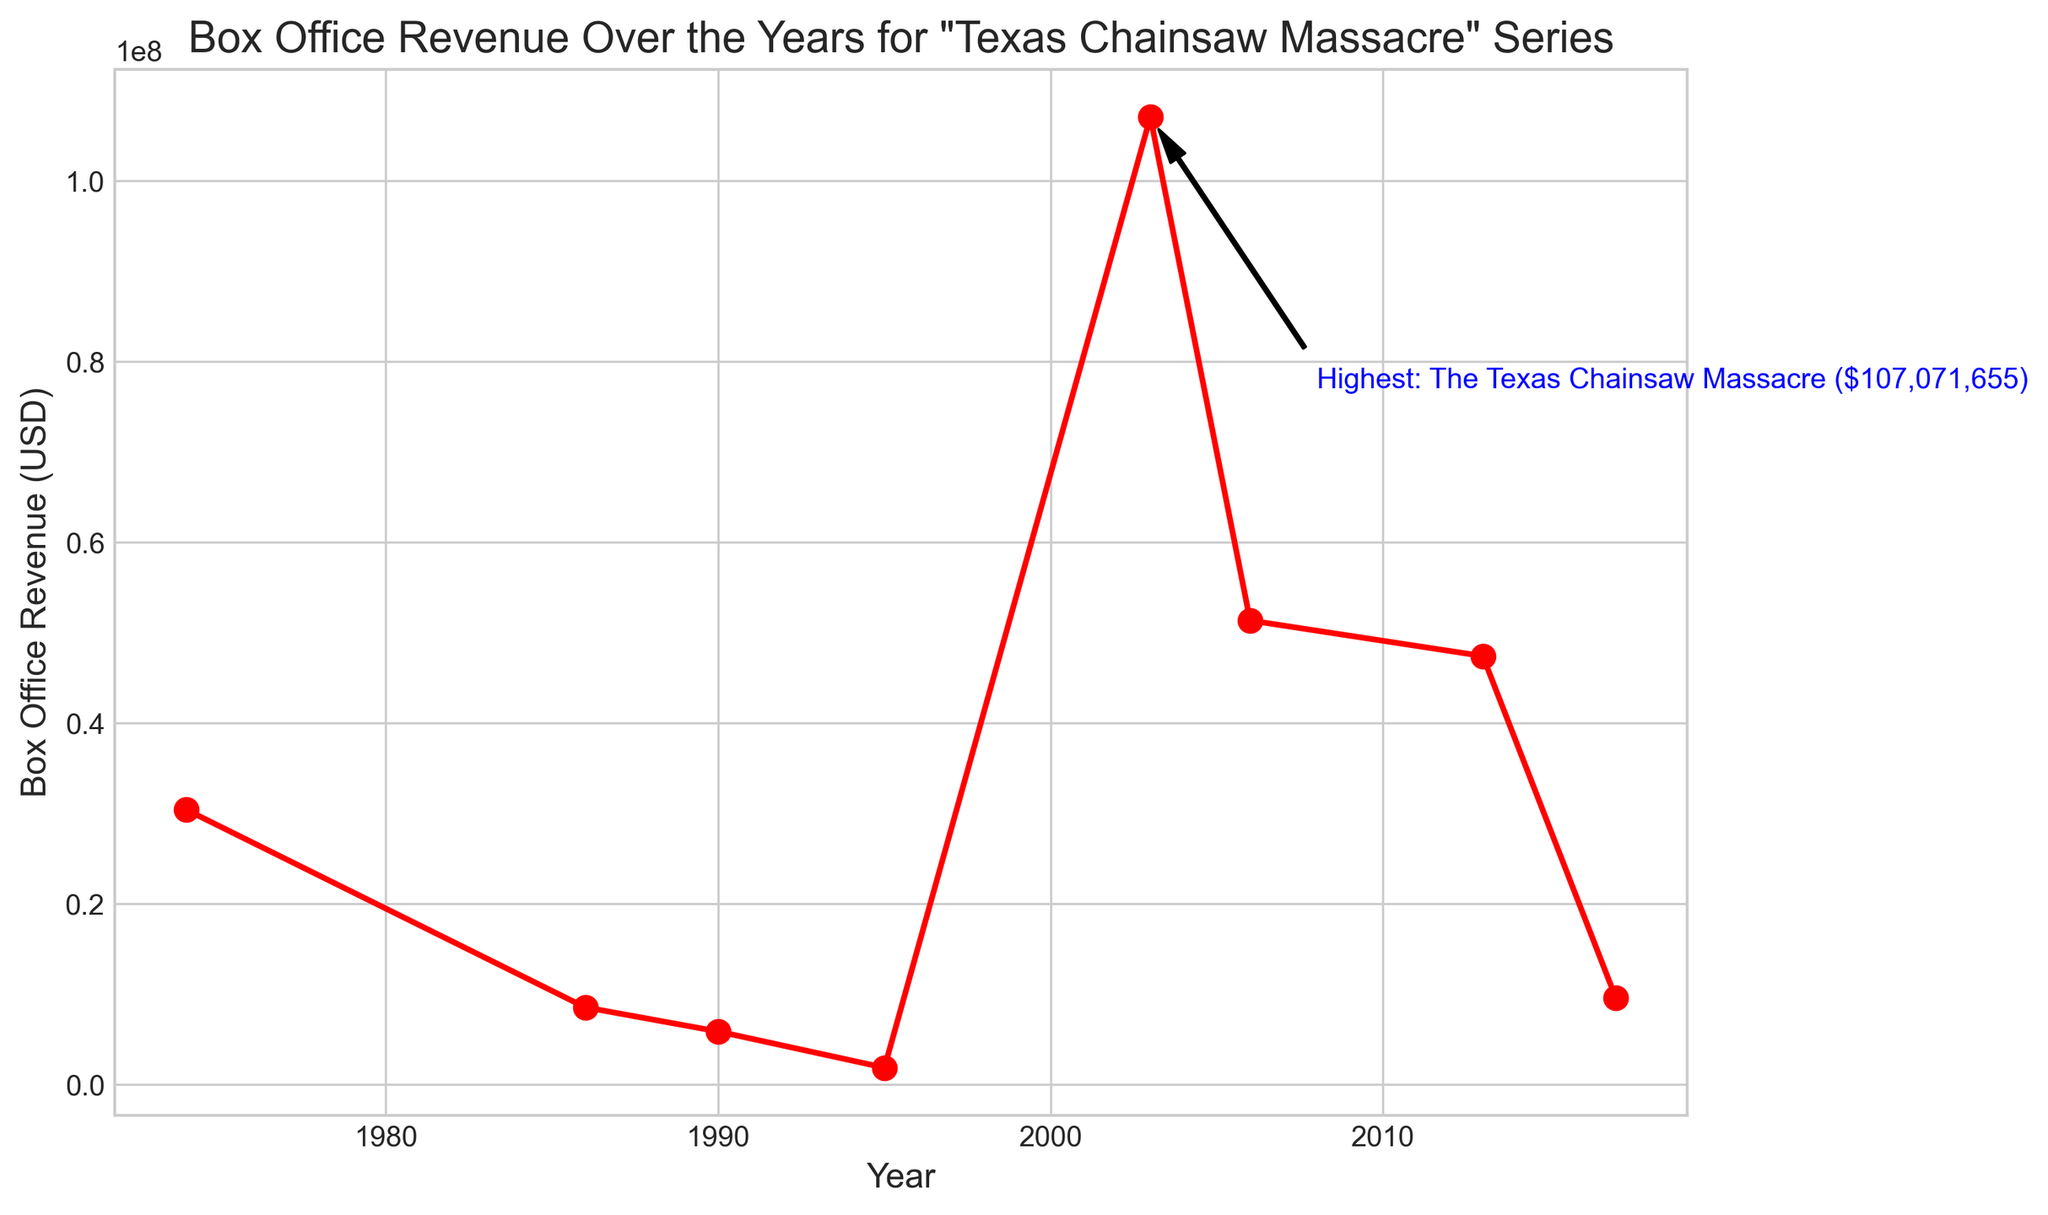What is the highest box office revenue among the "Texas Chainsaw Massacre" films? The highest box office revenue can be observed from the text annotation which identifies the highest-earning film. It states that "The Texas Chainsaw Massacre" (2003) earned $107,071,655.
Answer: $107,071,655 Which film had the lowest box office revenue, and what was it? By examining the lowest point on the line plot, we can see that the film "Texas Chainsaw Massacre: The Next Generation" in 1995 had the lowest box office revenue, which was $1,858,981.
Answer: "Texas Chainsaw Massacre: The Next Generation", $1,858,981 Which film experienced a significant increase in box office revenue compared to its predecessor? Finding the sharpest upward slope between consecutive points in the line chart reveals that there is a significant increase between "Texas Chainsaw Massacre: The Next Generation" (1995) and "The Texas Chainsaw Massacre" (2003), going from $1,858,981 to $107,071,655.
Answer: "The Texas Chainsaw Massacre" (2003) What is the total box office revenue of the films that were released after 2000? Adding the revenues of the films released after 2000 gives us: $107,071,655 + $51,345,281 + $47,410,379 + $9,585,863 = $215,413,178.
Answer: $215,413,178 How many films had a box office revenue greater than $50 million? By examining the points on the plot that exceed $50 million, two films stand out: "The Texas Chainsaw Massacre" (2003) and "The Texas Chainsaw Massacre: The Beginning" (2006). So, that makes two films.
Answer: 2 Which films earned less than $10 million, and what were their respective revenues? Identifying the points below $10 million on the plot, we have "Leatherface: The Texas Chainsaw Massacre III" (1990) at $5,862,371, "Texas Chainsaw Massacre: The Next Generation" (1995) at $1,858,981, and "Leatherface" (2017) at $9,585,863.
Answer: "Leatherface: The Texas Chainsaw Massacre III" ($5,862,371), "Texas Chainsaw Massacre: The Next Generation" ($1,858,981), "Leatherface" ($9,585,863) How does the box office revenue of "The Texas Chainsaw Massacre" (2003) compare to the combined revenue of all previous films in the series? Summing the revenues of all films before 2003 gives: $30,400,000 + $8,536,929 + $5,862,371 + $1,858,981 = $46,658,281. Comparing this to "The Texas Chainsaw Massacre" (2003), which earned $107,071,655, we see that 2003's film earned significantly more.
Answer: "The Texas Chainsaw Massacre" (2003) earned significantly more than the combined revenue of all previous films What is the average box office revenue of the series? Summing all the revenues and dividing by the number of films: ($30,400,000 + $8,536,929 + $5,862,371 + $1,858,981 + $107,071,655 + $51,345,281 + $47,410,379 + $9,585,863) / 8 = $32,871,432.375.
Answer: $32,871,432.375 